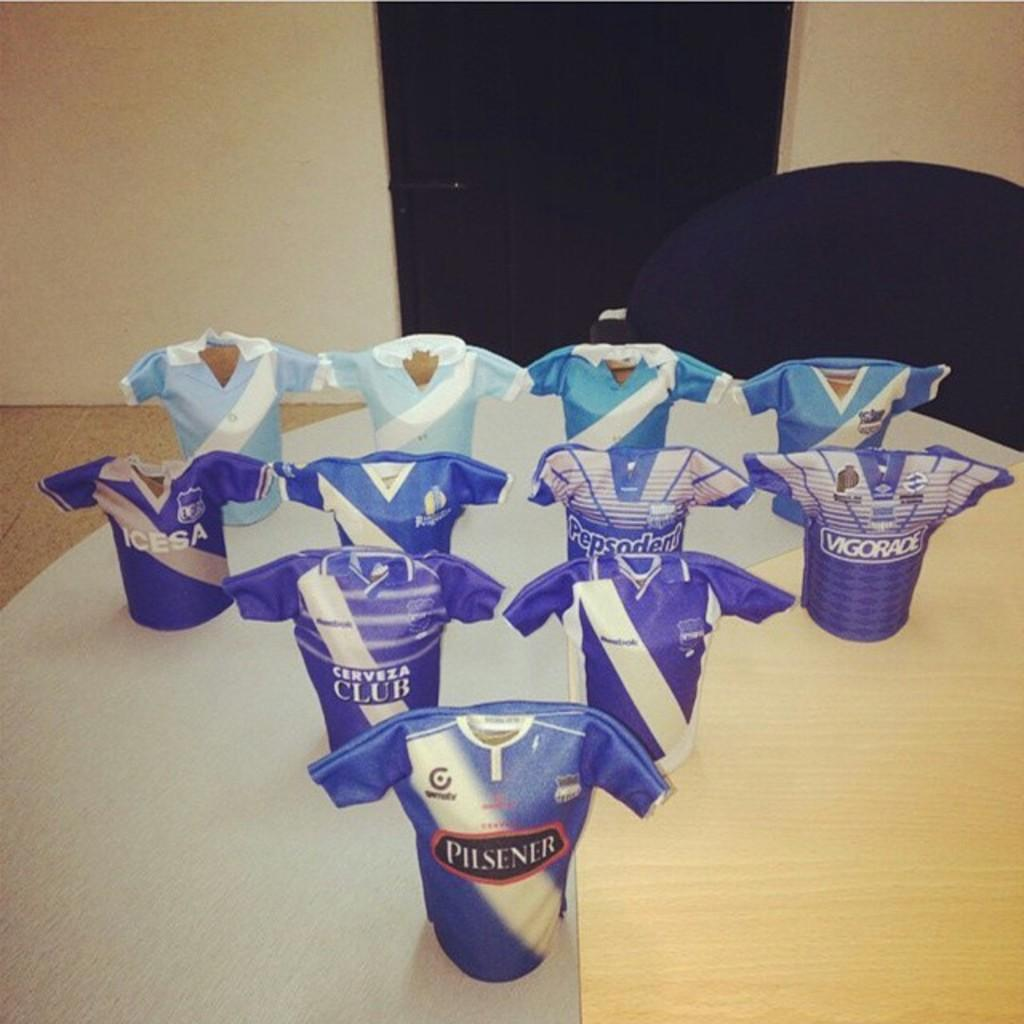<image>
Provide a brief description of the given image. A group of toy soccer jerseys with advertising from Pilsner and Cerveza Club among others. 